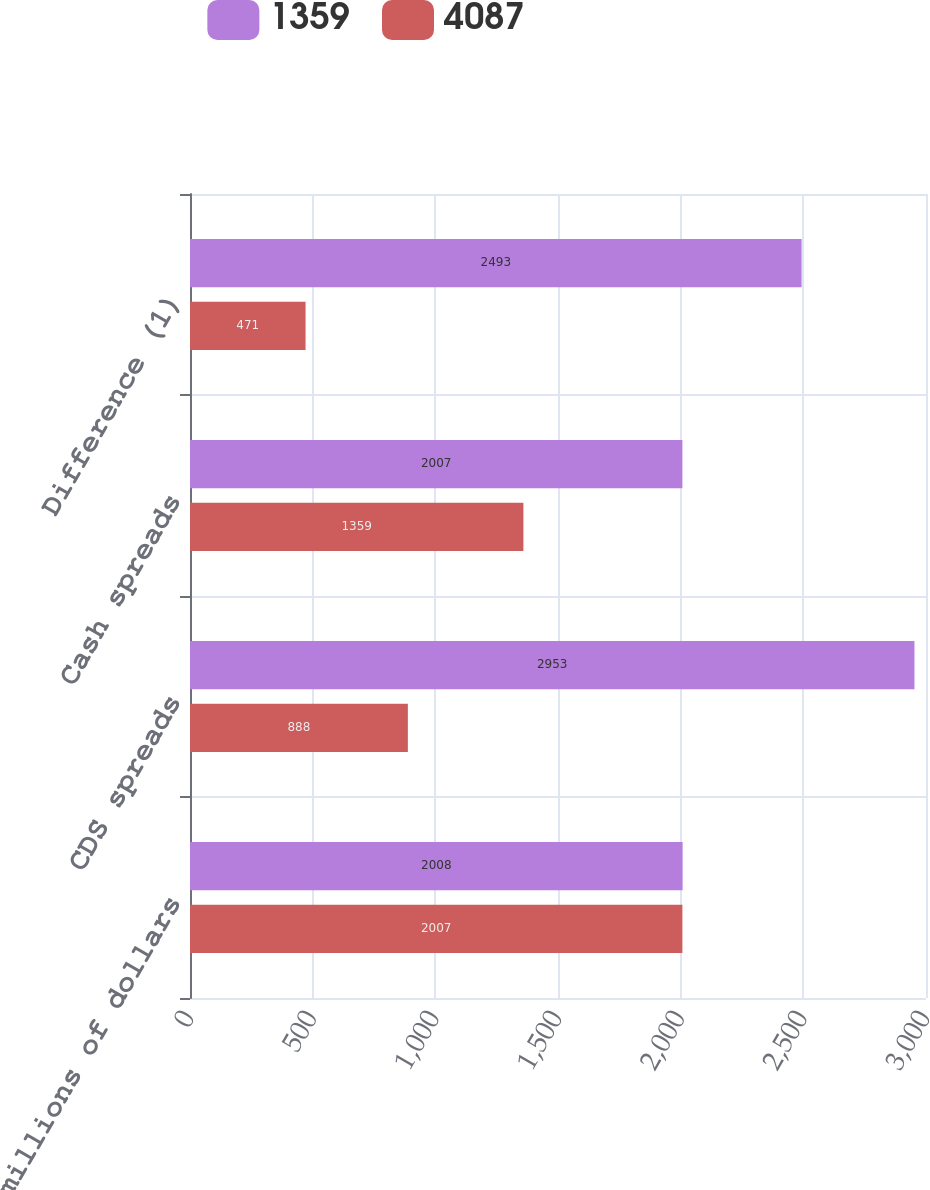Convert chart. <chart><loc_0><loc_0><loc_500><loc_500><stacked_bar_chart><ecel><fcel>In millions of dollars<fcel>CDS spreads<fcel>Cash spreads<fcel>Difference (1)<nl><fcel>1359<fcel>2008<fcel>2953<fcel>2007<fcel>2493<nl><fcel>4087<fcel>2007<fcel>888<fcel>1359<fcel>471<nl></chart> 